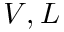<formula> <loc_0><loc_0><loc_500><loc_500>V , L</formula> 